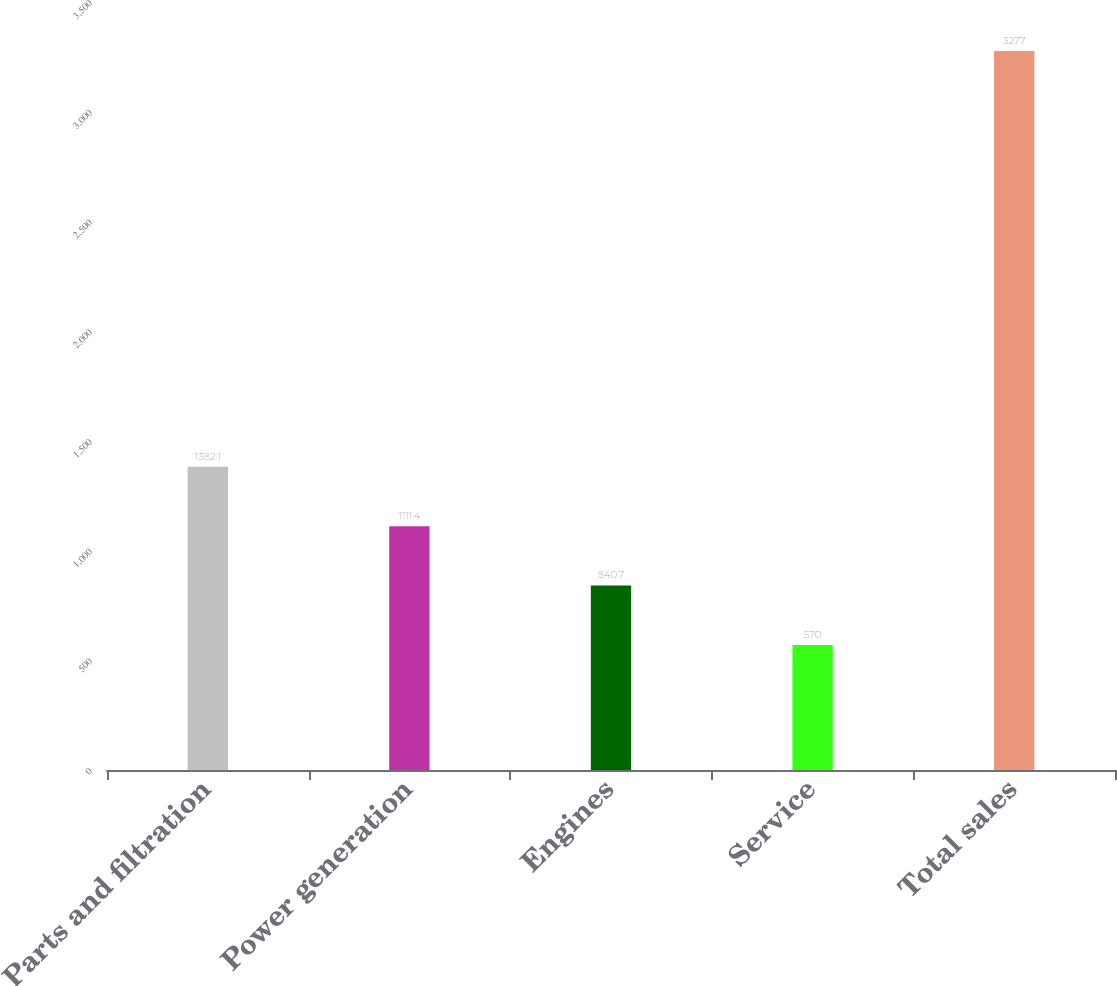Convert chart. <chart><loc_0><loc_0><loc_500><loc_500><bar_chart><fcel>Parts and filtration<fcel>Power generation<fcel>Engines<fcel>Service<fcel>Total sales<nl><fcel>1382.1<fcel>1111.4<fcel>840.7<fcel>570<fcel>3277<nl></chart> 